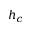Convert formula to latex. <formula><loc_0><loc_0><loc_500><loc_500>h _ { c }</formula> 